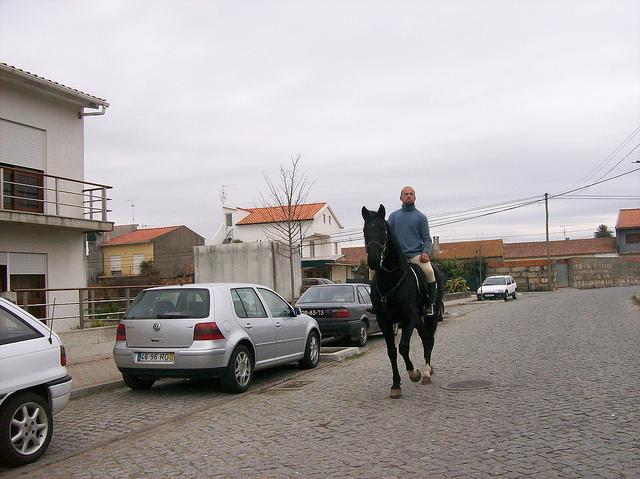What color is the car on the left?
Keep it brief. Silver. Are this goats?
Give a very brief answer. No. What is he riding on?
Short answer required. Horse. What is the man carrying?
Keep it brief. Nothing. How many horses are there?
Answer briefly. 1. What brand are these horses usually associated with?
Be succinct. Budweiser. What type of street is it?
Short answer required. Cobblestone. Are there more cars or more bicycles in this picture?
Quick response, please. Cars. What is the boy doing?
Concise answer only. Riding horse. What are the trucks pulling?
Be succinct. Nothing. What's behind the horse?
Answer briefly. Car. Is this a city street?
Quick response, please. No. What animal is in the picture?
Give a very brief answer. Horse. How many dump trucks are in this photo?
Write a very short answer. 0. Is the man riding a horse in the street?
Quick response, please. Yes. What is attached to the back trunk of the car?
Be succinct. License plate. What is this man doing?
Answer briefly. Riding horse. What is the man doing?
Quick response, please. Riding horse. What is the car's license plate?
Write a very short answer. 4696rg. Is the man smiling?
Concise answer only. No. What are parked along the side of street?
Write a very short answer. Cars. How many cars are there?
Write a very short answer. 4. 